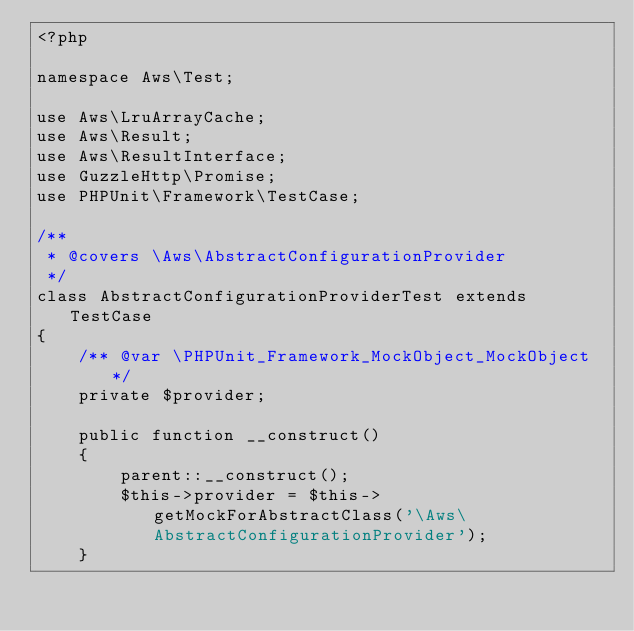Convert code to text. <code><loc_0><loc_0><loc_500><loc_500><_PHP_><?php

namespace Aws\Test;

use Aws\LruArrayCache;
use Aws\Result;
use Aws\ResultInterface;
use GuzzleHttp\Promise;
use PHPUnit\Framework\TestCase;

/**
 * @covers \Aws\AbstractConfigurationProvider
 */
class AbstractConfigurationProviderTest extends TestCase
{
    /** @var \PHPUnit_Framework_MockObject_MockObject */
    private $provider;

    public function __construct()
    {
        parent::__construct();
        $this->provider = $this->getMockForAbstractClass('\Aws\AbstractConfigurationProvider');
    }
</code> 